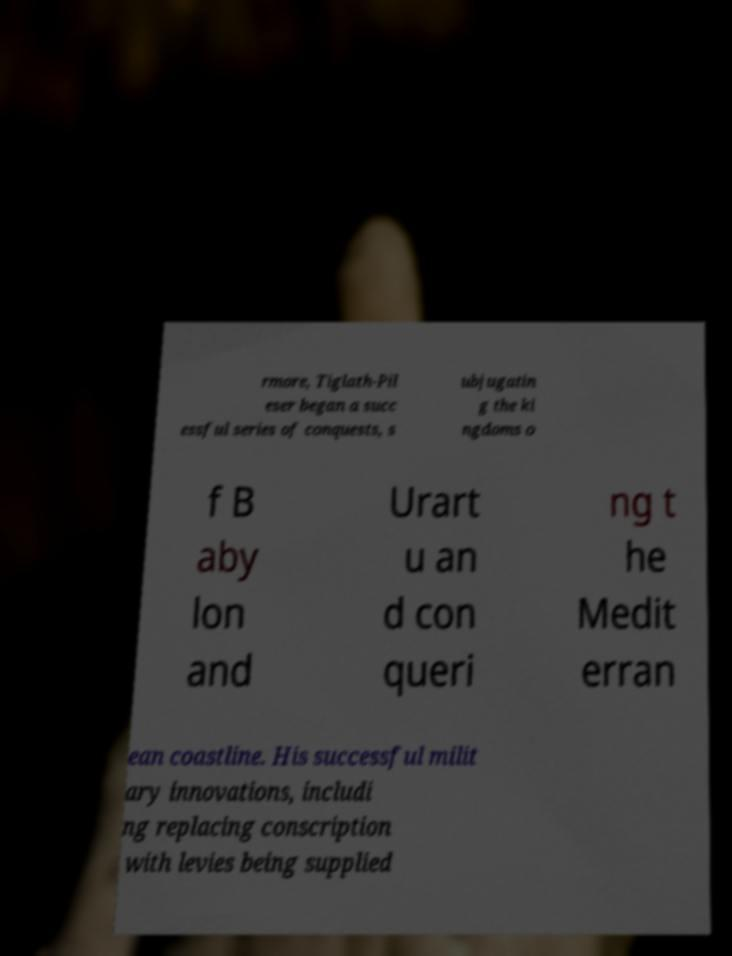There's text embedded in this image that I need extracted. Can you transcribe it verbatim? rmore, Tiglath-Pil eser began a succ essful series of conquests, s ubjugatin g the ki ngdoms o f B aby lon and Urart u an d con queri ng t he Medit erran ean coastline. His successful milit ary innovations, includi ng replacing conscription with levies being supplied 